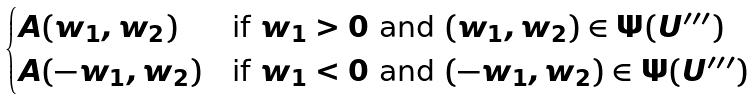Convert formula to latex. <formula><loc_0><loc_0><loc_500><loc_500>\begin{cases} A ( w _ { 1 } , w _ { 2 } ) & \text {if $w_{1}>0$ and $(w_{1},w_{2})\in\Psi(U^{\prime\prime\prime})$} \\ A ( - w _ { 1 } , w _ { 2 } ) & \text {if $w_{1}<0$ and $(-w_{1},w_{2})\in\Psi(U^{\prime\prime\prime})$} \end{cases}</formula> 